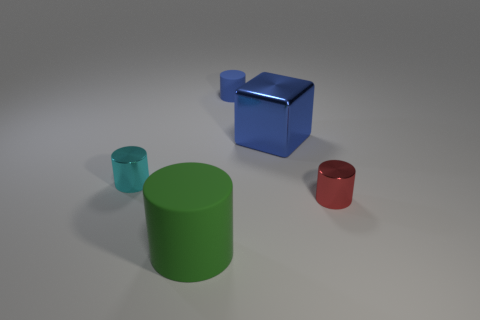How many other things are made of the same material as the blue cube? There are two other objects in the image that appear to be made of the same material - plastic or a plastic-like substance - as the blue cube, which are the green cylinder and the red cylinder. 